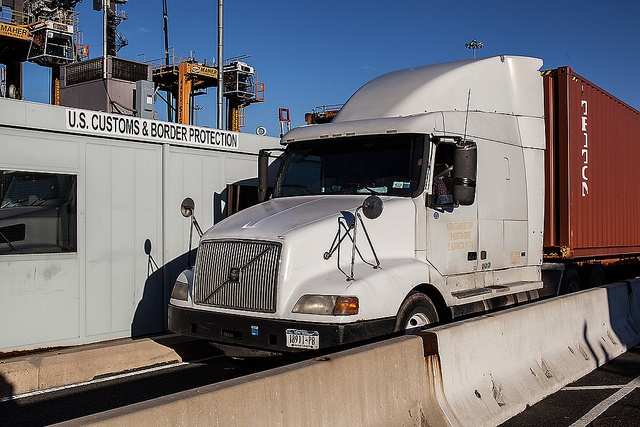Describe the objects in this image and their specific colors. I can see a truck in gray, black, lightgray, darkgray, and maroon tones in this image. 